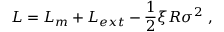<formula> <loc_0><loc_0><loc_500><loc_500>L = L _ { m } + L _ { e x t } - { \frac { 1 } { 2 } } \xi R \sigma ^ { 2 } ,</formula> 